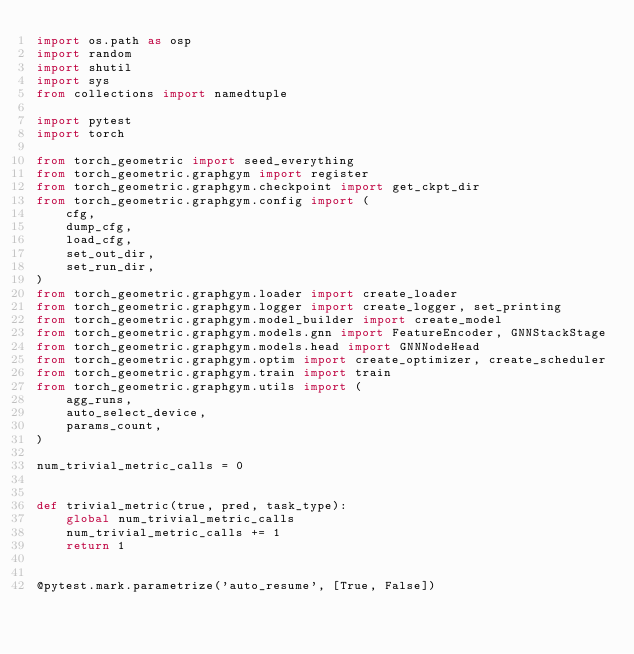Convert code to text. <code><loc_0><loc_0><loc_500><loc_500><_Python_>import os.path as osp
import random
import shutil
import sys
from collections import namedtuple

import pytest
import torch

from torch_geometric import seed_everything
from torch_geometric.graphgym import register
from torch_geometric.graphgym.checkpoint import get_ckpt_dir
from torch_geometric.graphgym.config import (
    cfg,
    dump_cfg,
    load_cfg,
    set_out_dir,
    set_run_dir,
)
from torch_geometric.graphgym.loader import create_loader
from torch_geometric.graphgym.logger import create_logger, set_printing
from torch_geometric.graphgym.model_builder import create_model
from torch_geometric.graphgym.models.gnn import FeatureEncoder, GNNStackStage
from torch_geometric.graphgym.models.head import GNNNodeHead
from torch_geometric.graphgym.optim import create_optimizer, create_scheduler
from torch_geometric.graphgym.train import train
from torch_geometric.graphgym.utils import (
    agg_runs,
    auto_select_device,
    params_count,
)

num_trivial_metric_calls = 0


def trivial_metric(true, pred, task_type):
    global num_trivial_metric_calls
    num_trivial_metric_calls += 1
    return 1


@pytest.mark.parametrize('auto_resume', [True, False])</code> 